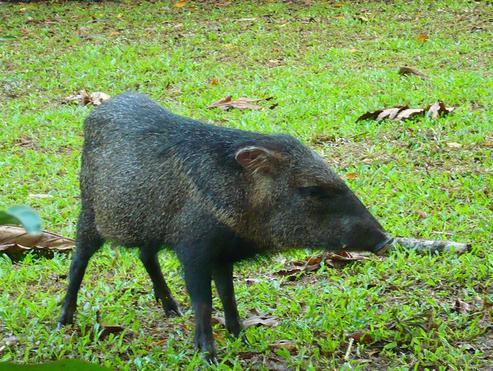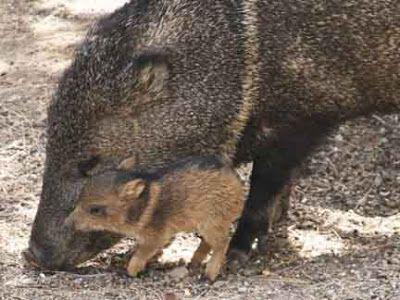The first image is the image on the left, the second image is the image on the right. For the images shown, is this caption "In one image, the animals are standing on grass that is green." true? Answer yes or no. Yes. The first image is the image on the left, the second image is the image on the right. For the images shown, is this caption "The pigs are standing on yellow leaves in one image and not in the other." true? Answer yes or no. No. 